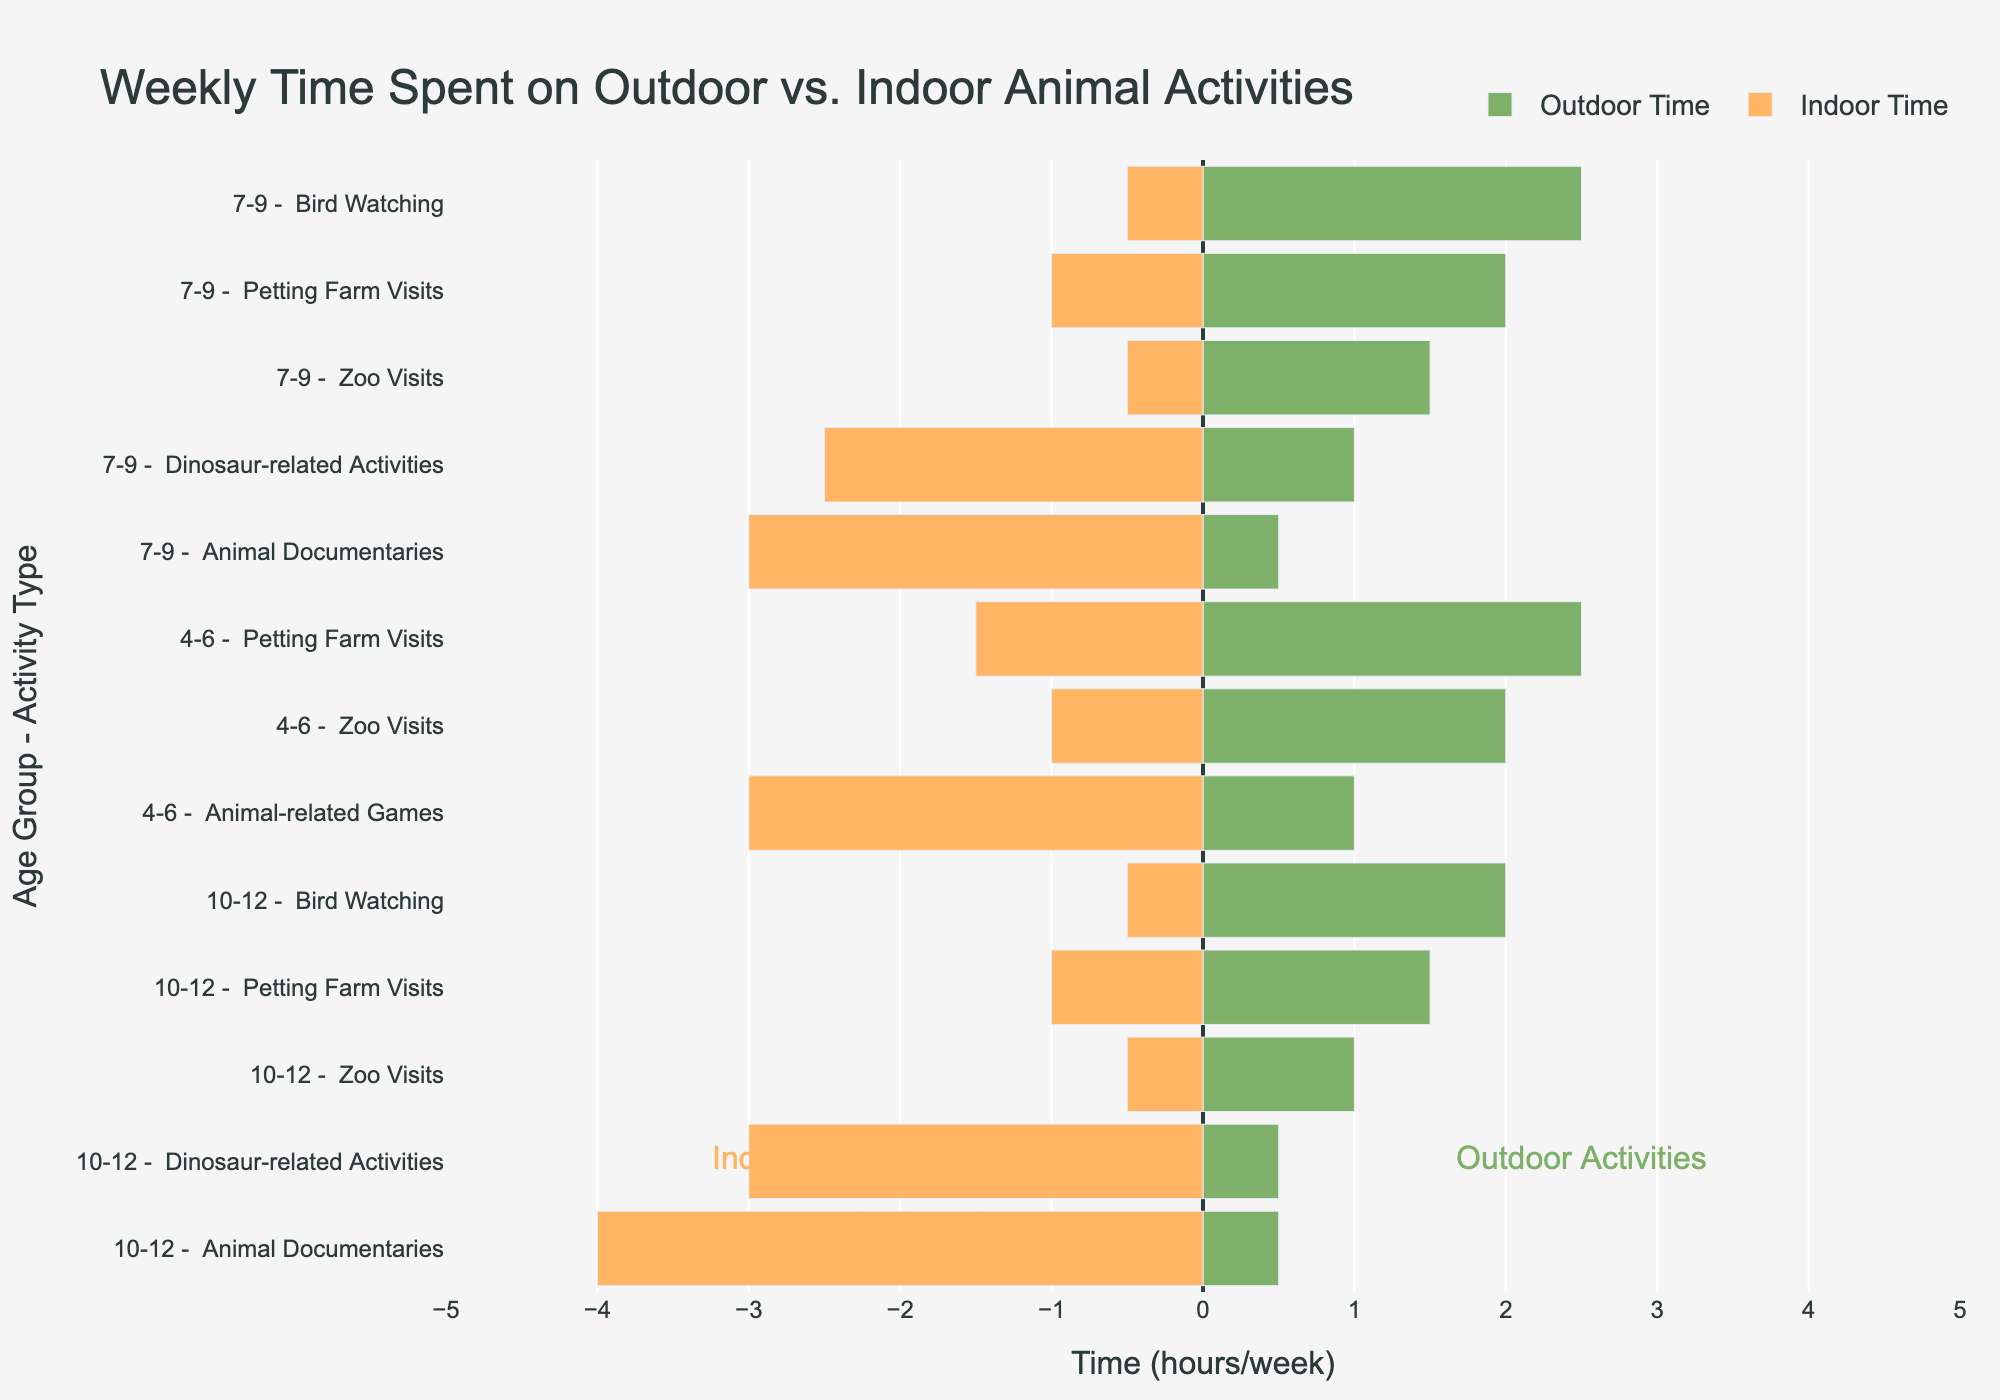What activity spends an equal amount of time both outdoors and indoors for the 4-6 age group? The figure shows that for the 4-6 age group, Zoo Visits takes 2 hours outdoors and 1 hour indoors, Petting Farm Visits takes 2.5 hours outdoors and 1.5 hours indoors, and Animal-related Games takes 1 hour outdoors and 3 hours indoors. None of these activities spend an equal amount of time outdoors and indoors.
Answer: None Which activity do children aged 7-9 spend the most time on? For children aged 7-9, the activities listed are Zoo Visits (1.5 hours outdoors, 0.5 hours indoors), Petting Farm Visits (2 hours outdoors, 1 hour indoors), Bird Watching (2.5 hours outdoors, 0.5 hours indoors), Animal Documentaries (0.5 hours outdoors, 3 hours indoors), and Dinosaur-related Activities (1 hour outdoors, 2.5 hours indoors). The most time spent is on Animal Documentaries, which is 3 hours indoors.
Answer: Animal Documentaries What is the total weekly time spent on Petting Farm Visits for all age groups? For the 4-6 age group, Petting Farm Visits take 2.5 hours outdoors and 1.5 hours indoors. For the 7-9 age group, they take 2 hours outdoors and 1 hour indoors. For the 10-12 age group, they take 1.5 hours outdoors and 1 hour indoors. Summing these gives 6 hours outdoors and 3.5 hours indoors, making a total of 9.5 hours.
Answer: 9.5 hours Compare the time spent on Zoo Visits across all age groups. For the 4-6 age group, Zoo Visits take 2 hours outdoors and 1 hour indoors. For the 7-9 age group, they take 1.5 hours outdoors and 0.5 hours indoors. For the 10-12 age group, they take 1 hour outdoors and 0.5 hours indoors. The trend shows that younger children spend more time on Zoo Visits than older children.
Answer: 4-6 > 7-9 > 10-12 What is the difference in time spent on Bird Watching between the age groups 7-9 and 10-12? For the 7-9 age group, Bird Watching takes 2.5 hours outdoors and 0.5 hours indoors. For the 10-12 age group, Bird Watching takes 2 hours outdoors and 0.5 hours indoors. The difference between 7-9 and 10-12 is 0.5 hours outdoors and 0 hours indoors.
Answer: 0.5 hours outdoors, 0 hours indoors Which activity among the 10-12 age group has the most significant difference between outdoor and indoor time? For the 10-12 age group, the activities listed are Zoo Visits (1 hour outdoors, 0.5 hours indoors), Petting Farm Visits (1.5 hours outdoors, 1 hour indoors), Bird Watching (2 hours outdoors, 0.5 hours indoors), Animal Documentaries (0.5 hours outdoors, 4 hours indoors), and Dinosaur-related Activities (0.5 hours outdoors, 3 hours indoors). The most significant difference is in Animal Documentaries, with a difference of 3.5 hours.
Answer: Animal Documentaries 